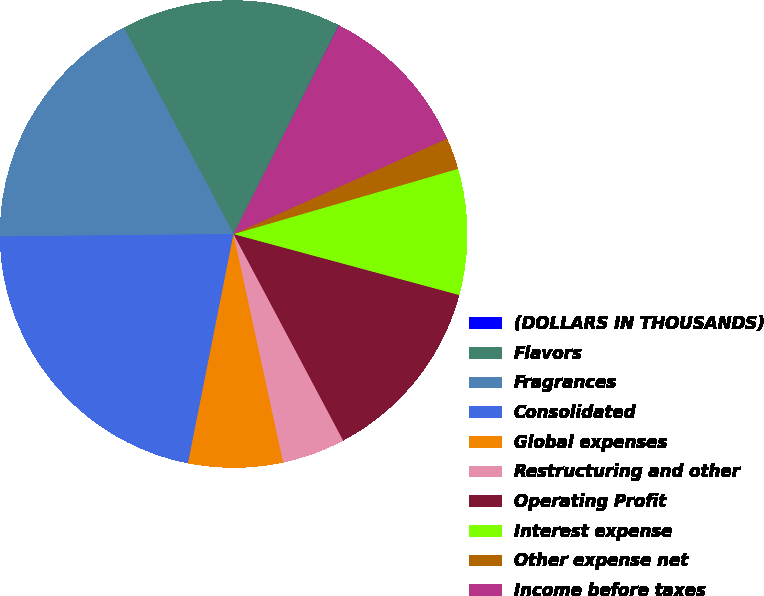Convert chart. <chart><loc_0><loc_0><loc_500><loc_500><pie_chart><fcel>(DOLLARS IN THOUSANDS)<fcel>Flavors<fcel>Fragrances<fcel>Consolidated<fcel>Global expenses<fcel>Restructuring and other<fcel>Operating Profit<fcel>Interest expense<fcel>Other expense net<fcel>Income before taxes<nl><fcel>0.02%<fcel>15.21%<fcel>17.38%<fcel>21.72%<fcel>6.53%<fcel>4.36%<fcel>13.04%<fcel>8.7%<fcel>2.19%<fcel>10.87%<nl></chart> 